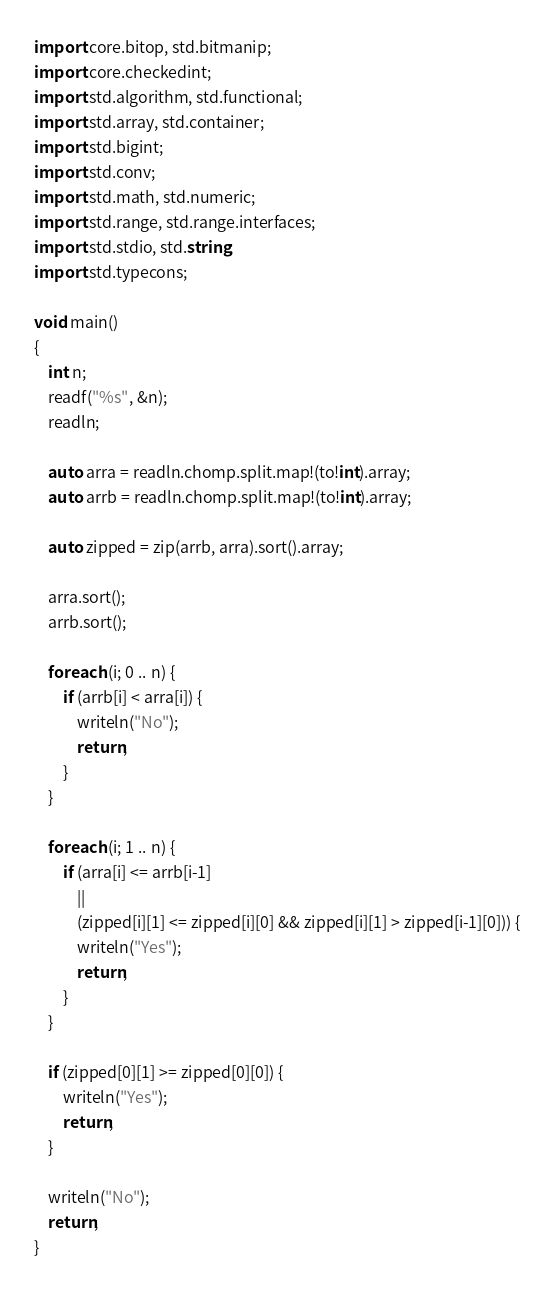Convert code to text. <code><loc_0><loc_0><loc_500><loc_500><_D_>import core.bitop, std.bitmanip;
import core.checkedint;
import std.algorithm, std.functional;
import std.array, std.container;
import std.bigint;
import std.conv;
import std.math, std.numeric;
import std.range, std.range.interfaces;
import std.stdio, std.string;
import std.typecons;

void main()
{
    int n;
    readf("%s", &n);
    readln;
    
    auto arra = readln.chomp.split.map!(to!int).array;
    auto arrb = readln.chomp.split.map!(to!int).array;
    
    auto zipped = zip(arrb, arra).sort().array;
    
    arra.sort();
    arrb.sort();
    
    foreach (i; 0 .. n) {
        if (arrb[i] < arra[i]) {
            writeln("No");
            return;
        }
    }
    
    foreach (i; 1 .. n) {
        if (arra[i] <= arrb[i-1]
            || 
            (zipped[i][1] <= zipped[i][0] && zipped[i][1] > zipped[i-1][0])) {
            writeln("Yes");
            return;
        }
    }
    
    if (zipped[0][1] >= zipped[0][0]) {
        writeln("Yes");
        return;
    }
    
    writeln("No");
    return;
}</code> 